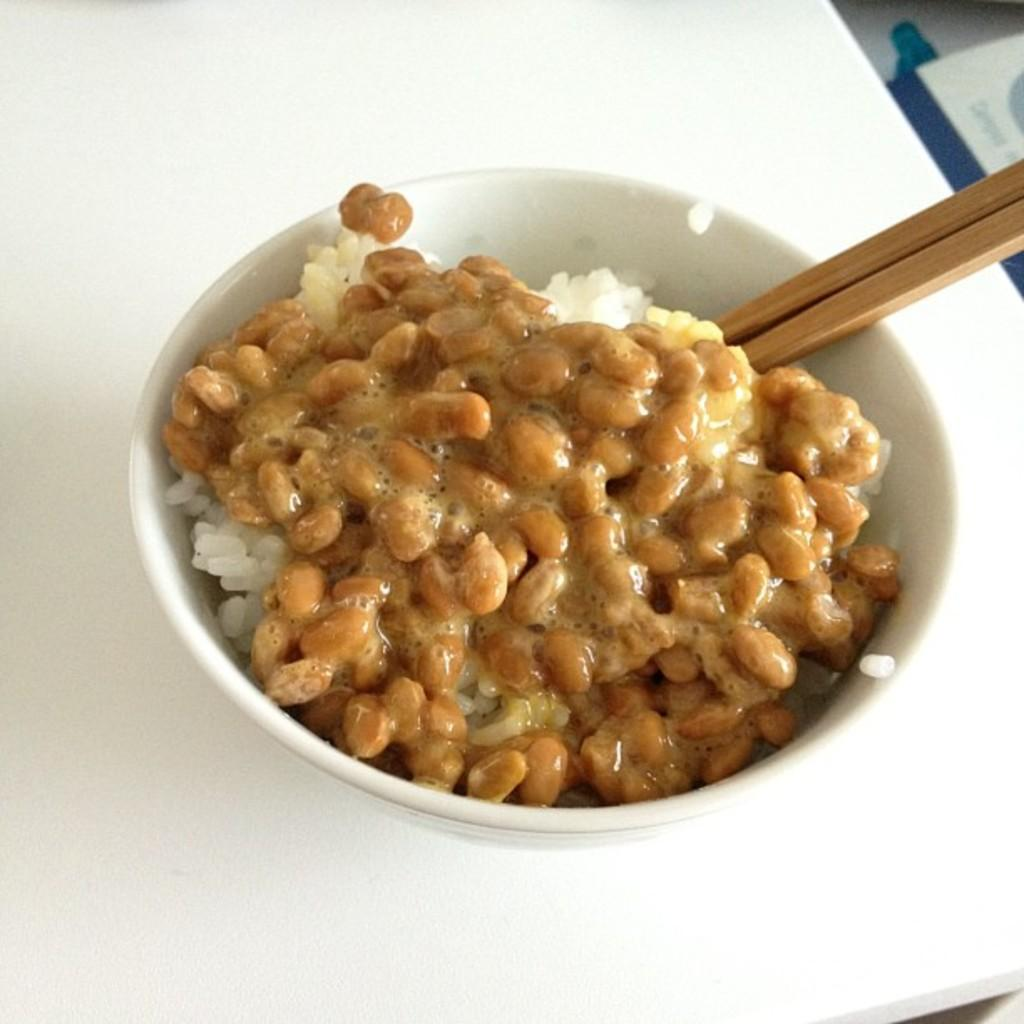What type of food is visible in the image? The food in the image is not specified, but it is highlighted. How is the food presented in the image? The food is presented in a bowl. What utensil is visible in the image? Chopsticks are visible in the image. How many sisters are present in the image? There are no sisters mentioned or visible in the image. What type of iron object can be seen in the image? There is no iron object present in the image. 